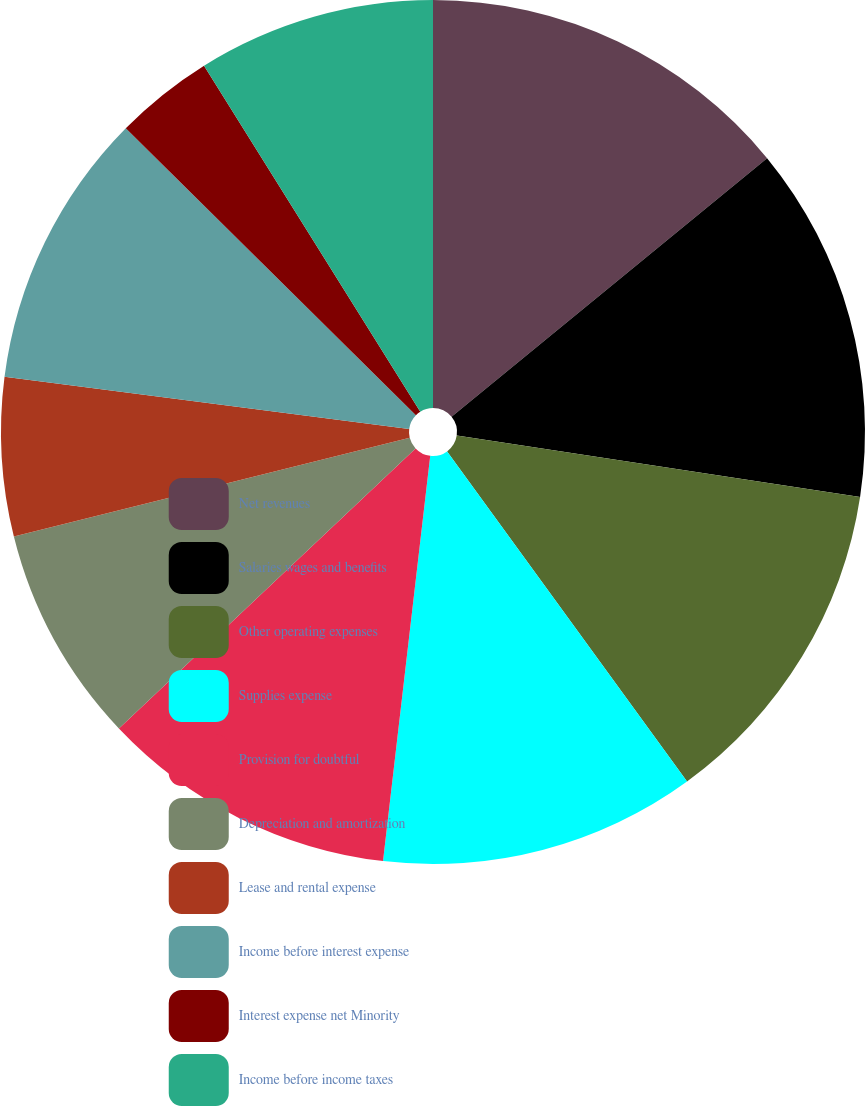Convert chart. <chart><loc_0><loc_0><loc_500><loc_500><pie_chart><fcel>Net revenues<fcel>Salaries wages and benefits<fcel>Other operating expenses<fcel>Supplies expense<fcel>Provision for doubtful<fcel>Depreciation and amortization<fcel>Lease and rental expense<fcel>Income before interest expense<fcel>Interest expense net Minority<fcel>Income before income taxes<nl><fcel>14.07%<fcel>13.33%<fcel>12.59%<fcel>11.85%<fcel>11.11%<fcel>8.15%<fcel>5.93%<fcel>10.37%<fcel>3.7%<fcel>8.89%<nl></chart> 